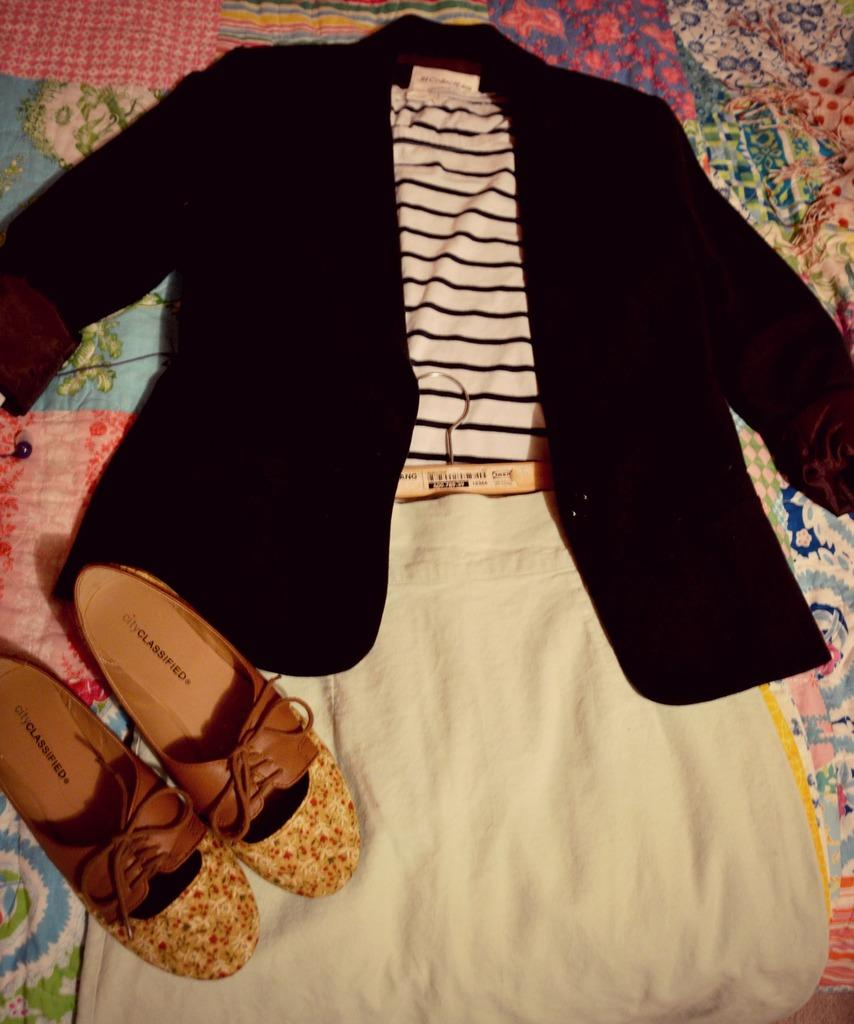<image>
Render a clear and concise summary of the photo. Two City Classified shoes are on top of a dress. 